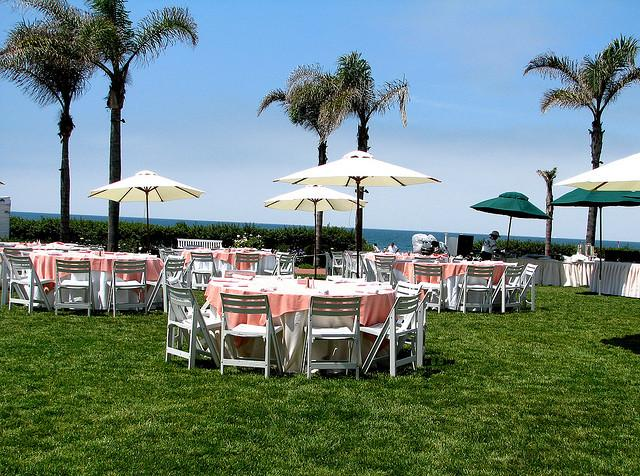What will be happening here in the very near future?

Choices:
A) school class
B) church service
C) yacht sailing
D) large party large party 